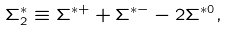<formula> <loc_0><loc_0><loc_500><loc_500>\Sigma ^ { * } _ { 2 } \equiv \Sigma ^ { * + } + \Sigma ^ { * - } - 2 \Sigma ^ { * 0 } ,</formula> 